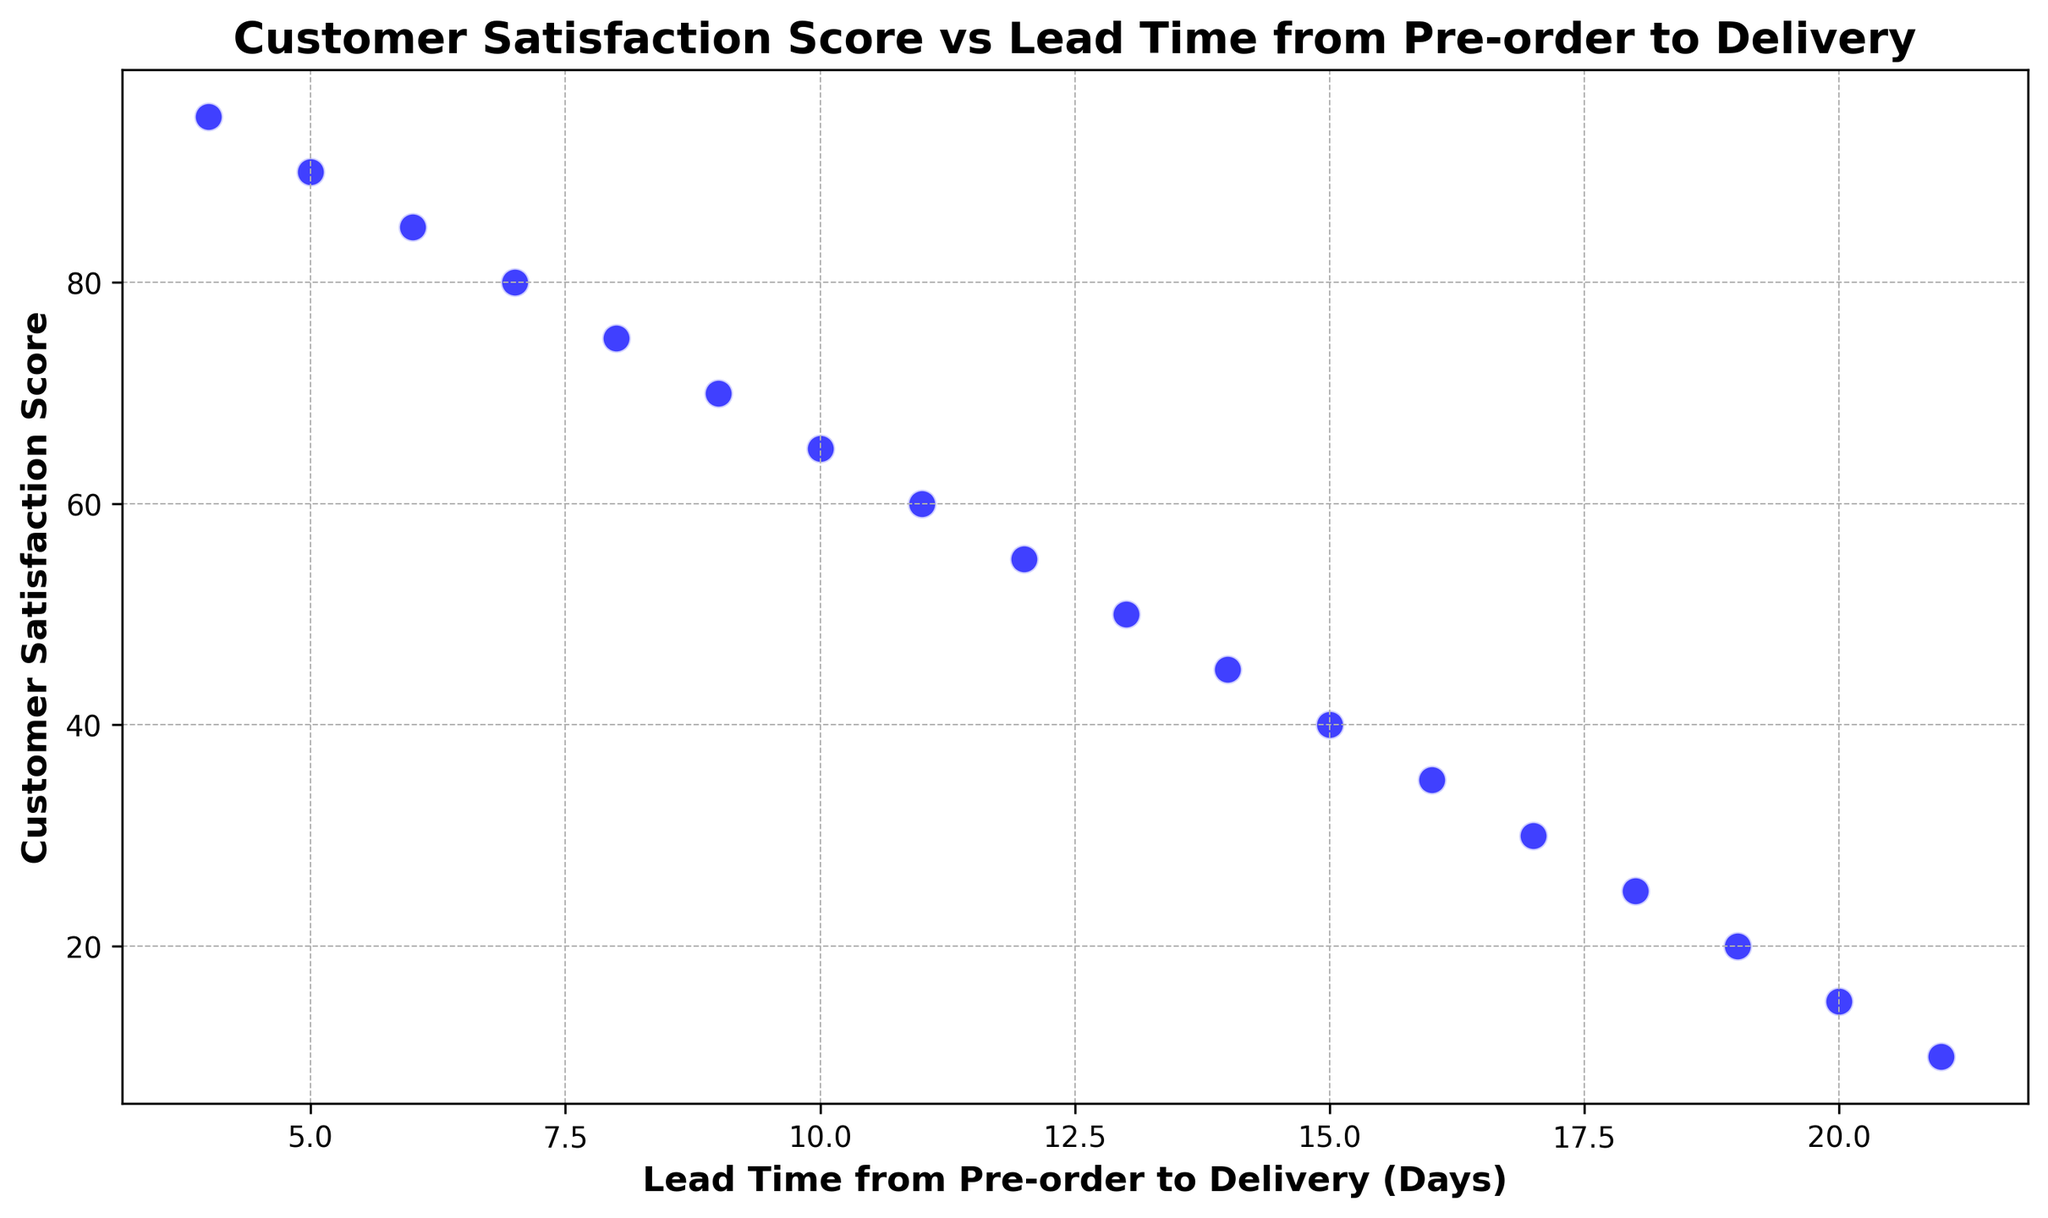which lead time has the highest satisfaction score? The plot shows a decreasing trend where Customer Satisfaction Score decreases as Lead Time increases. The highest satisfaction score is at the shortest lead time. By identifying the point with the highest satisfaction score of 95, we trace it to its corresponding lead time, which is 4 days.
Answer: 4 days what is the difference in satisfaction score between the shortest and longest lead times? To find the difference in satisfaction score, identify the scores for the shortest and longest lead times. The shortest lead time (4 days) has a satisfaction score of 95, and the longest lead time (21 days) has a satisfaction score of 10. The difference is 95 - 10 = 85.
Answer: 85 what is the average satisfaction score for lead times between 6 and 10 days? First, identify the satisfaction scores for lead times between 6 and 10 days: 85, 80, 75, 70, and 65. Calculate the average by summing these scores (85 + 80 + 75 + 70 + 65 = 375) and dividing by the number of data points (375 / 5 = 75).
Answer: 75 how does the satisfaction score change as lead time increases from 4 to 12 days? Observe the trend in satisfaction scores from a lead time of 4 days to 12 days: 95, 90, 85, 80, 75, 70, 65,  and 60. The score consistently decreases as lead time increases.
Answer: Decreases is there any lead time that has a satisfaction score less than 30? By inspecting the plot, identify if any satisfaction score falls below 30. Points with lead times 17, 18, 19, 20, and 21 days have scores of 30, 25, 20, 15, and 10 respectively, which are all less than 30.
Answer: Yes what is the rate of decrease in satisfaction score per day for lead times between 10 and 20 days? First calculate the difference in satisfaction scores and the difference in lead times. Satisfaction scores for 10 and 20 days are 65 and 15, respectively, giving a difference of 50 (65 - 15). The lead time difference is 10 days (20 - 10). The rate of decrease per day is 50/10 = 5 satisfaction points per day.
Answer: 5 points per day comparatively, which has a steeper trend, lead times from 4 to 10 days or from 15 to 21 days? Calculate the change in satisfaction scores and lead times for each range. From 4 to 10 days: scores 95 to 65, with a difference of 30 points over 6 days (30/6 = 5 points/day). From 15 to 21 days: scores 40 to 10, with a difference of 30 points over 6 days (30/6 = 5 points/day). Both trends are equally steep.
Answer: Equal what is the median satisfaction score for the entire dataset? Order the satisfaction scores and find the middle value. The ordered scores are: 10, 15, 20, 25, 30, 35, 40, 45, 50, 55, 60, 65, 70, 75, 80, 85, 90, 95. The median value, being the average of 9th and 10th scores (50 and 55), is (50 + 55) / 2 = 52.5.
Answer: 52.5 